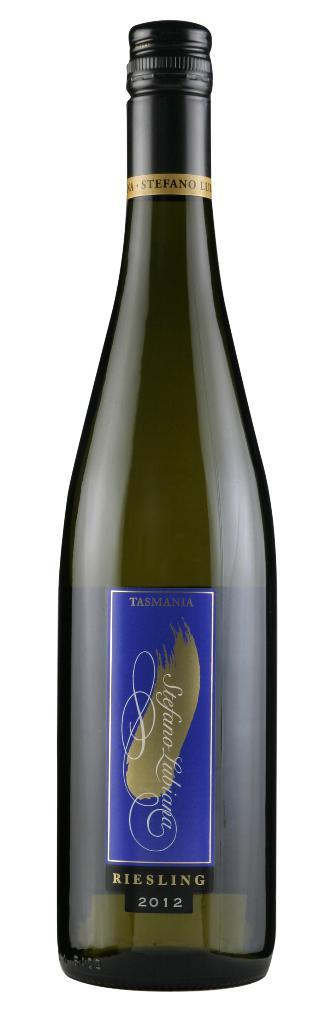<image>
Present a compact description of the photo's key features. A bottle of Tasmania riesling from 2012 has a blue label. 